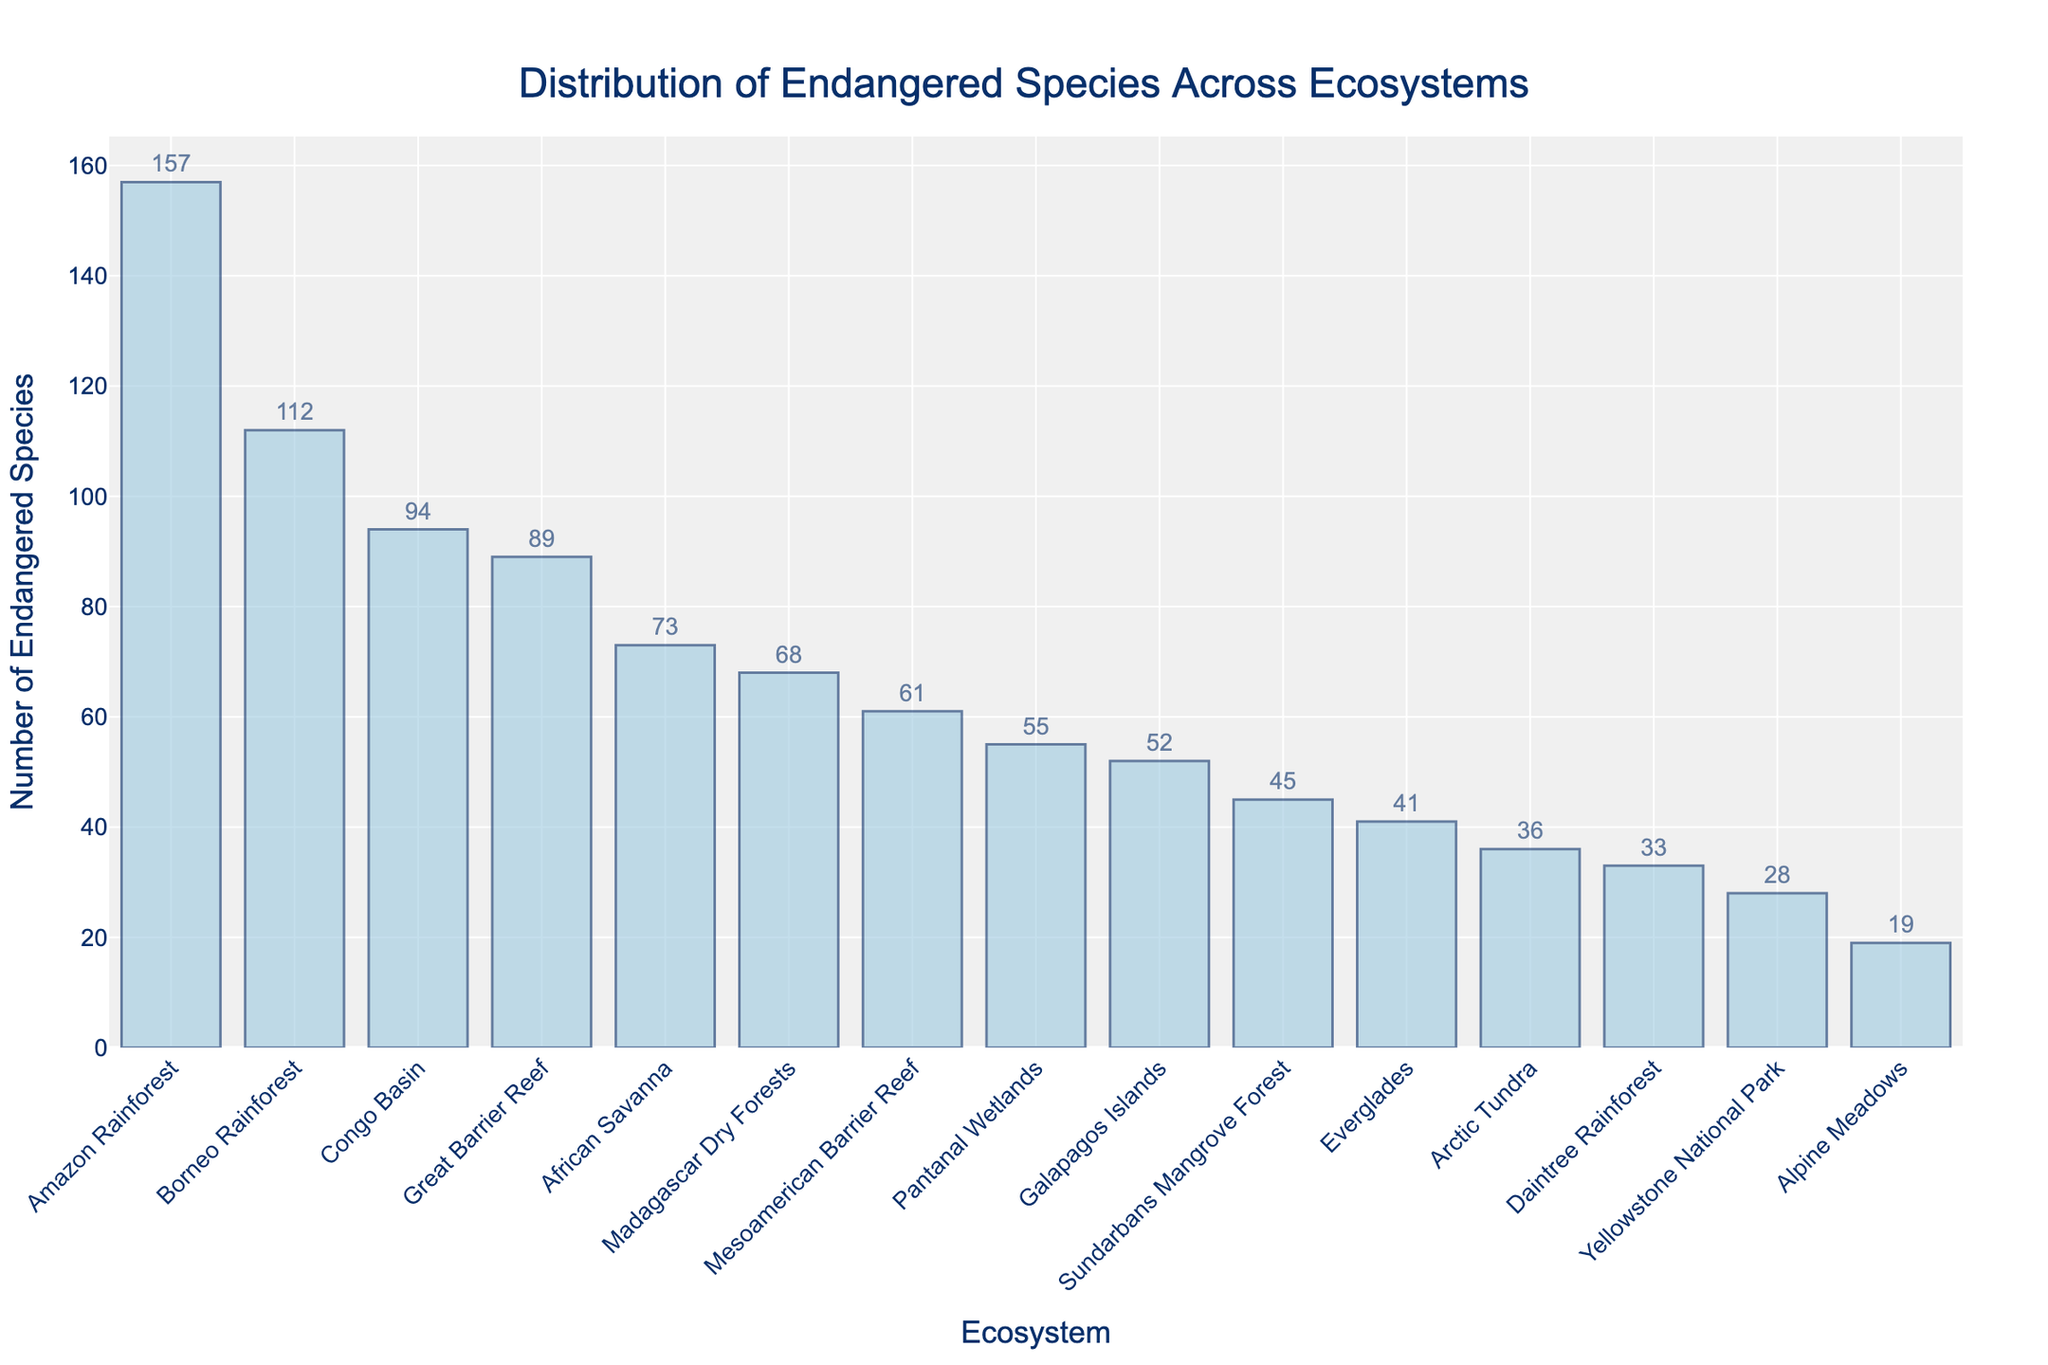Which ecosystem has the highest number of endangered species? The height of each bar represents the number of endangered species. The tallest bar signifies the ecosystem with the highest number. Here, the Amazon Rainforest has the tallest bar.
Answer: Amazon Rainforest Which ecosystem has the lowest number of endangered species? The height of each bar represents the number of endangered species. The shortest bar signifies the ecosystem with the lowest number. Here, Alpine Meadows has the shortest bar.
Answer: Alpine Meadows How many more endangered species are there in the Borneo Rainforest compared to the Great Barrier Reef? Identify the heights of the bars for Borneo Rainforest and Great Barrier Reef. The Borneo Rainforest has 112 species and the Great Barrier Reef has 89 species. Subtract the latter from the former (112 - 89).
Answer: 23 Are there more endangered species in the Congo Basin or the Galapagos Islands? Compare the heights of the bars for Congo Basin and Galapagos Islands. The Congo Basin’s bar is taller indicating more species.
Answer: Congo Basin What is the total number of endangered species in the Amazon Rainforest, Arctic Tundra, and Pantanal Wetlands combined? Sum the heights of the bars (the values) for Amazon Rainforest (157), Arctic Tundra (36), and Pantanal Wetlands (55). 157 + 36 + 55 = 248
Answer: 248 Which ecosystem ranks second in the number of endangered species? Order the bars by height from tallest to shortest. The second tallest is the bar for the Borneo Rainforest.
Answer: Borneo Rainforest How does the number of endangered species in Yellowstone National Park compare to the Sundarbans Mangrove Forest? Compare the bar heights for Yellowstone National Park and Sundarbans Mangrove Forest. The Sundarbans Mangrove Forest’s bar is taller.
Answer: Sundarbans Mangrove Forest What is the median number of endangered species across all ecosystems presented? Sort the numbers of endangered species: [19, 28, 33, 36, 41, 45, 52, 55, 61, 68, 73, 89, 94, 112, 157]. The median is the middle value of this ordered list.
Answer: 55 What is the difference in the number of endangered species between the Amazon Rainforest and the Everglades? Subtract the number of endangered species in the Everglades (41) from the number in the Amazon Rainforest (157). 157 - 41 = 116
Answer: 116 What is the range of the number of endangered species across all ecosystems? Find the difference between the highest value (Amazon Rainforest, 157) and the lowest value (Alpine Meadows, 19). 157 - 19 = 138
Answer: 138 